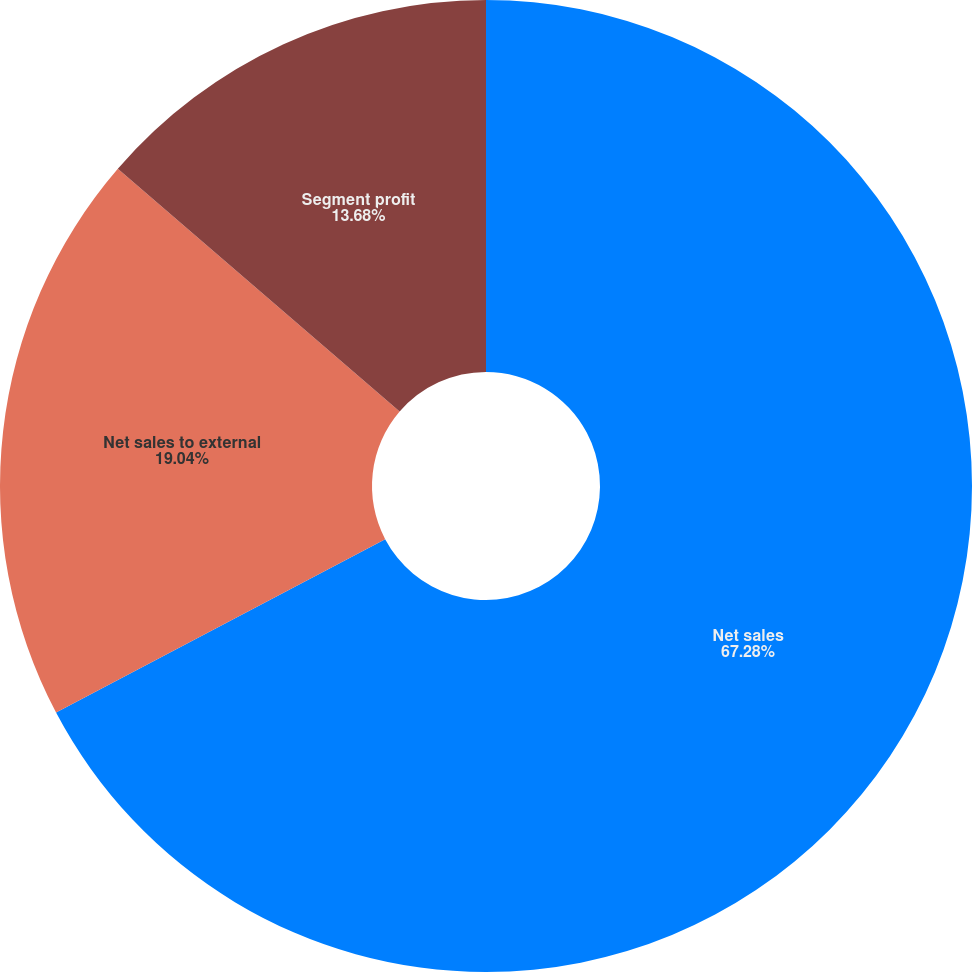<chart> <loc_0><loc_0><loc_500><loc_500><pie_chart><fcel>Net sales<fcel>Net sales to external<fcel>Segment profit<nl><fcel>67.28%<fcel>19.04%<fcel>13.68%<nl></chart> 